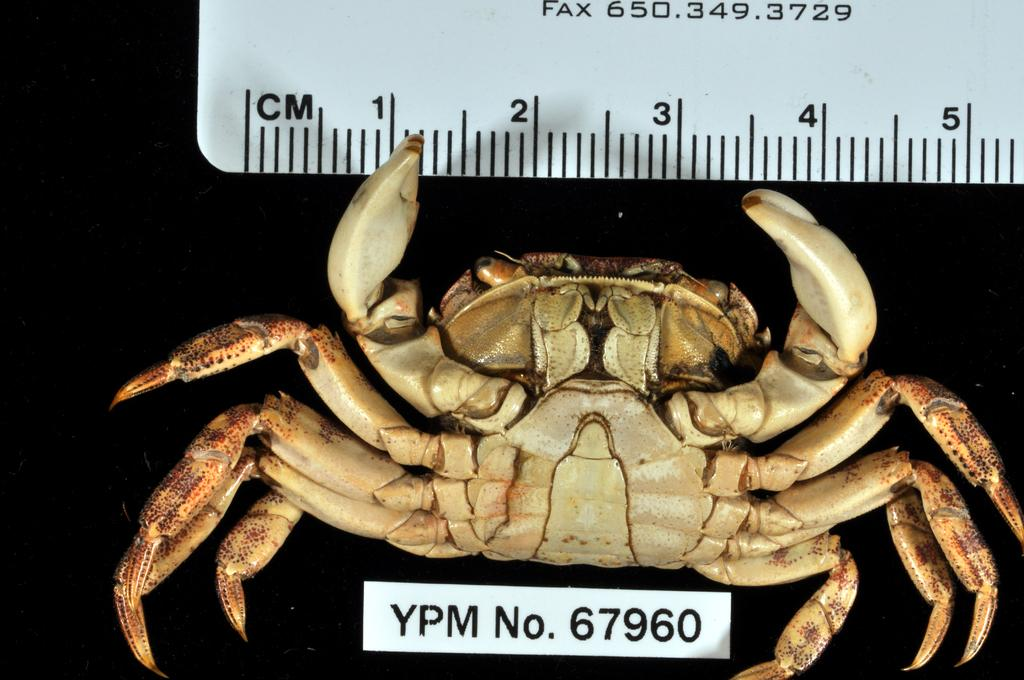What type of animal is in the image? There is a crab in the image. What colors can be seen on the crab? The crab has cream and brown colors. What object is present in the image that is used for measuring? There is a white color scale in the image. What is written on the scale? Something is written on the scale, but the specific text is not mentioned in the facts. What color is the background of the image? The background of the image is black. What type of carriage is used to transport the crab in the image? There is no carriage present in the image, and the crab is not being transported. How does the truck help the crab in the image? There is no truck present in the image, and the crab does not require assistance from a truck. 